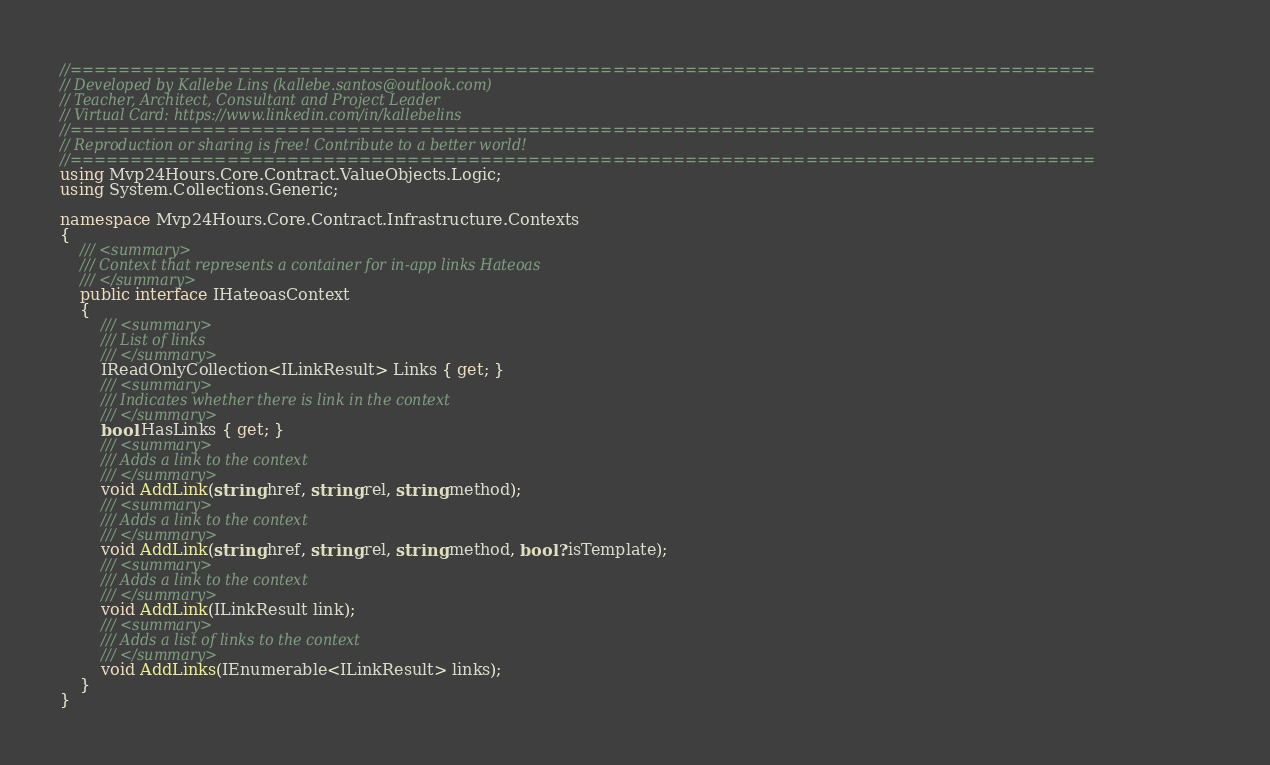Convert code to text. <code><loc_0><loc_0><loc_500><loc_500><_C#_>//=====================================================================================
// Developed by Kallebe Lins (kallebe.santos@outlook.com)
// Teacher, Architect, Consultant and Project Leader
// Virtual Card: https://www.linkedin.com/in/kallebelins
//=====================================================================================
// Reproduction or sharing is free! Contribute to a better world!
//=====================================================================================
using Mvp24Hours.Core.Contract.ValueObjects.Logic;
using System.Collections.Generic;

namespace Mvp24Hours.Core.Contract.Infrastructure.Contexts
{
    /// <summary>
    /// Context that represents a container for in-app links Hateoas
    /// </summary>
    public interface IHateoasContext
    {
        /// <summary>
        /// List of links
        /// </summary>
        IReadOnlyCollection<ILinkResult> Links { get; }
        /// <summary>
        /// Indicates whether there is link in the context
        /// </summary>
        bool HasLinks { get; }
        /// <summary>
        /// Adds a link to the context
        /// </summary>
        void AddLink(string href, string rel, string method);
        /// <summary>
        /// Adds a link to the context
        /// </summary>
        void AddLink(string href, string rel, string method, bool? isTemplate);
        /// <summary>
        /// Adds a link to the context
        /// </summary>
        void AddLink(ILinkResult link);
        /// <summary>
        /// Adds a list of links to the context
        /// </summary>
        void AddLinks(IEnumerable<ILinkResult> links);
    }
}
</code> 